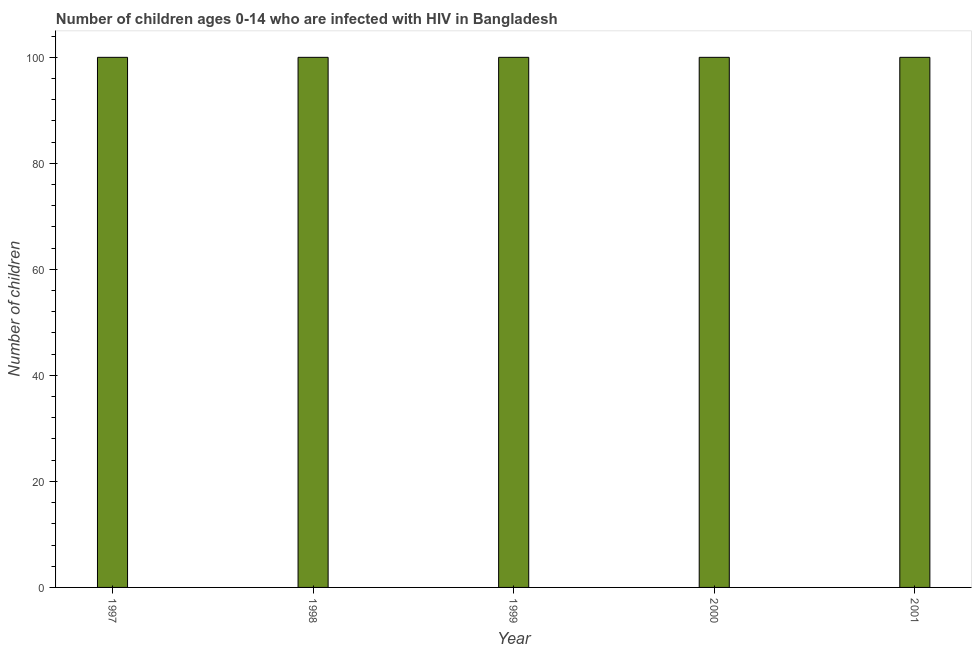Does the graph contain any zero values?
Give a very brief answer. No. What is the title of the graph?
Make the answer very short. Number of children ages 0-14 who are infected with HIV in Bangladesh. What is the label or title of the Y-axis?
Provide a short and direct response. Number of children. What is the number of children living with hiv in 1998?
Offer a terse response. 100. What is the sum of the number of children living with hiv?
Offer a terse response. 500. What is the difference between the number of children living with hiv in 1999 and 2001?
Provide a succinct answer. 0. What is the median number of children living with hiv?
Your answer should be very brief. 100. In how many years, is the number of children living with hiv greater than 8 ?
Your answer should be compact. 5. Is the number of children living with hiv in 1999 less than that in 2001?
Keep it short and to the point. No. What is the difference between the highest and the second highest number of children living with hiv?
Offer a terse response. 0. How many bars are there?
Your answer should be compact. 5. Are all the bars in the graph horizontal?
Provide a succinct answer. No. How many years are there in the graph?
Your answer should be very brief. 5. Are the values on the major ticks of Y-axis written in scientific E-notation?
Your answer should be compact. No. What is the Number of children in 1997?
Your answer should be compact. 100. What is the Number of children in 1998?
Provide a succinct answer. 100. What is the Number of children of 2000?
Your response must be concise. 100. What is the Number of children in 2001?
Give a very brief answer. 100. What is the difference between the Number of children in 1997 and 1998?
Ensure brevity in your answer.  0. What is the difference between the Number of children in 1997 and 1999?
Provide a short and direct response. 0. What is the difference between the Number of children in 1997 and 2001?
Provide a succinct answer. 0. What is the difference between the Number of children in 1998 and 2000?
Provide a succinct answer. 0. What is the difference between the Number of children in 1999 and 2000?
Your answer should be compact. 0. What is the difference between the Number of children in 1999 and 2001?
Ensure brevity in your answer.  0. What is the difference between the Number of children in 2000 and 2001?
Your answer should be very brief. 0. What is the ratio of the Number of children in 1997 to that in 1999?
Ensure brevity in your answer.  1. What is the ratio of the Number of children in 1997 to that in 2000?
Provide a short and direct response. 1. What is the ratio of the Number of children in 1997 to that in 2001?
Your answer should be compact. 1. What is the ratio of the Number of children in 1998 to that in 1999?
Your answer should be compact. 1. What is the ratio of the Number of children in 1998 to that in 2001?
Make the answer very short. 1. What is the ratio of the Number of children in 1999 to that in 2000?
Give a very brief answer. 1. What is the ratio of the Number of children in 1999 to that in 2001?
Offer a very short reply. 1. What is the ratio of the Number of children in 2000 to that in 2001?
Provide a short and direct response. 1. 